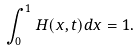<formula> <loc_0><loc_0><loc_500><loc_500>\int ^ { 1 } _ { 0 } H ( x , t ) d x = 1 .</formula> 